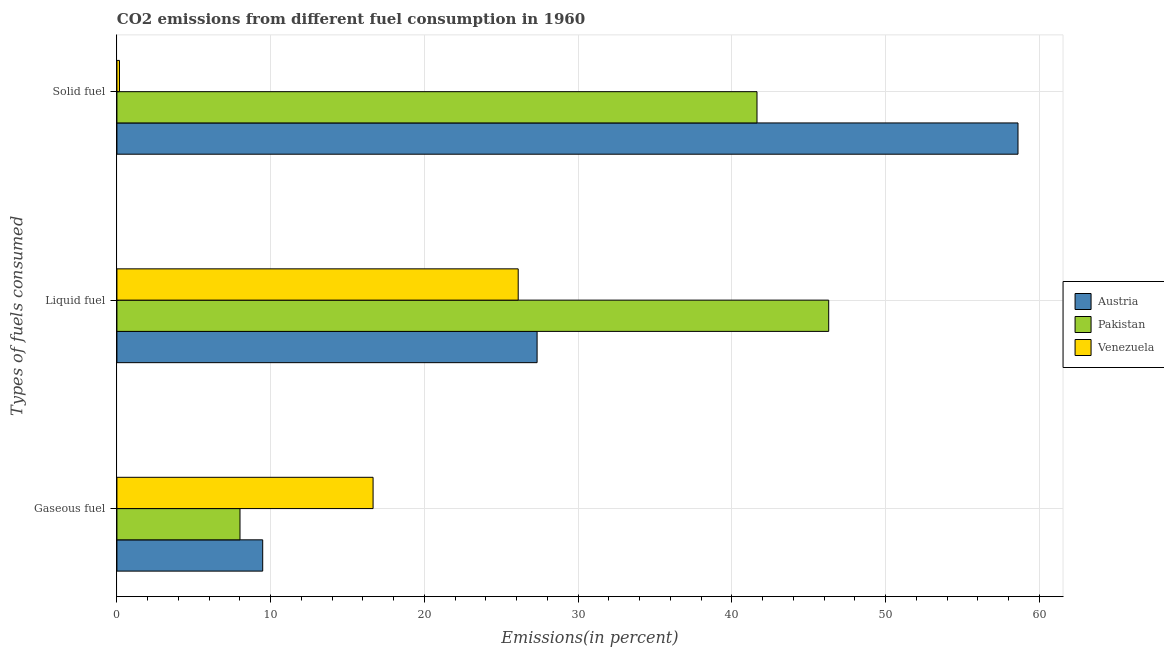How many different coloured bars are there?
Your response must be concise. 3. How many groups of bars are there?
Ensure brevity in your answer.  3. Are the number of bars on each tick of the Y-axis equal?
Your response must be concise. Yes. How many bars are there on the 2nd tick from the bottom?
Keep it short and to the point. 3. What is the label of the 1st group of bars from the top?
Ensure brevity in your answer.  Solid fuel. What is the percentage of gaseous fuel emission in Venezuela?
Offer a very short reply. 16.66. Across all countries, what is the maximum percentage of gaseous fuel emission?
Offer a very short reply. 16.66. Across all countries, what is the minimum percentage of liquid fuel emission?
Your answer should be compact. 26.1. In which country was the percentage of liquid fuel emission maximum?
Provide a succinct answer. Pakistan. In which country was the percentage of liquid fuel emission minimum?
Offer a terse response. Venezuela. What is the total percentage of solid fuel emission in the graph?
Ensure brevity in your answer.  100.41. What is the difference between the percentage of gaseous fuel emission in Austria and that in Venezuela?
Your answer should be compact. -7.18. What is the difference between the percentage of liquid fuel emission in Austria and the percentage of gaseous fuel emission in Pakistan?
Make the answer very short. 19.32. What is the average percentage of gaseous fuel emission per country?
Ensure brevity in your answer.  11.38. What is the difference between the percentage of liquid fuel emission and percentage of gaseous fuel emission in Austria?
Your answer should be very brief. 17.85. In how many countries, is the percentage of gaseous fuel emission greater than 2 %?
Your response must be concise. 3. What is the ratio of the percentage of liquid fuel emission in Pakistan to that in Austria?
Your answer should be very brief. 1.69. What is the difference between the highest and the second highest percentage of gaseous fuel emission?
Provide a succinct answer. 7.18. What is the difference between the highest and the lowest percentage of gaseous fuel emission?
Give a very brief answer. 8.66. What does the 3rd bar from the top in Liquid fuel represents?
Offer a very short reply. Austria. What does the 3rd bar from the bottom in Liquid fuel represents?
Provide a succinct answer. Venezuela. How many bars are there?
Your answer should be compact. 9. What is the difference between two consecutive major ticks on the X-axis?
Your response must be concise. 10. Are the values on the major ticks of X-axis written in scientific E-notation?
Keep it short and to the point. No. How many legend labels are there?
Offer a terse response. 3. How are the legend labels stacked?
Your answer should be very brief. Vertical. What is the title of the graph?
Your answer should be very brief. CO2 emissions from different fuel consumption in 1960. Does "French Polynesia" appear as one of the legend labels in the graph?
Your answer should be compact. No. What is the label or title of the X-axis?
Your response must be concise. Emissions(in percent). What is the label or title of the Y-axis?
Your answer should be compact. Types of fuels consumed. What is the Emissions(in percent) of Austria in Gaseous fuel?
Give a very brief answer. 9.48. What is the Emissions(in percent) of Pakistan in Gaseous fuel?
Your answer should be compact. 8.01. What is the Emissions(in percent) of Venezuela in Gaseous fuel?
Offer a terse response. 16.66. What is the Emissions(in percent) in Austria in Liquid fuel?
Your answer should be compact. 27.33. What is the Emissions(in percent) of Pakistan in Liquid fuel?
Ensure brevity in your answer.  46.3. What is the Emissions(in percent) of Venezuela in Liquid fuel?
Ensure brevity in your answer.  26.1. What is the Emissions(in percent) in Austria in Solid fuel?
Offer a terse response. 58.61. What is the Emissions(in percent) of Pakistan in Solid fuel?
Your answer should be compact. 41.63. What is the Emissions(in percent) in Venezuela in Solid fuel?
Offer a very short reply. 0.17. Across all Types of fuels consumed, what is the maximum Emissions(in percent) of Austria?
Offer a terse response. 58.61. Across all Types of fuels consumed, what is the maximum Emissions(in percent) in Pakistan?
Provide a succinct answer. 46.3. Across all Types of fuels consumed, what is the maximum Emissions(in percent) of Venezuela?
Provide a short and direct response. 26.1. Across all Types of fuels consumed, what is the minimum Emissions(in percent) of Austria?
Ensure brevity in your answer.  9.48. Across all Types of fuels consumed, what is the minimum Emissions(in percent) of Pakistan?
Offer a very short reply. 8.01. Across all Types of fuels consumed, what is the minimum Emissions(in percent) of Venezuela?
Your response must be concise. 0.17. What is the total Emissions(in percent) of Austria in the graph?
Ensure brevity in your answer.  95.42. What is the total Emissions(in percent) of Pakistan in the graph?
Give a very brief answer. 95.93. What is the total Emissions(in percent) of Venezuela in the graph?
Offer a terse response. 42.93. What is the difference between the Emissions(in percent) in Austria in Gaseous fuel and that in Liquid fuel?
Ensure brevity in your answer.  -17.85. What is the difference between the Emissions(in percent) of Pakistan in Gaseous fuel and that in Liquid fuel?
Provide a succinct answer. -38.29. What is the difference between the Emissions(in percent) in Venezuela in Gaseous fuel and that in Liquid fuel?
Keep it short and to the point. -9.44. What is the difference between the Emissions(in percent) in Austria in Gaseous fuel and that in Solid fuel?
Give a very brief answer. -49.13. What is the difference between the Emissions(in percent) of Pakistan in Gaseous fuel and that in Solid fuel?
Offer a very short reply. -33.63. What is the difference between the Emissions(in percent) of Venezuela in Gaseous fuel and that in Solid fuel?
Your response must be concise. 16.49. What is the difference between the Emissions(in percent) in Austria in Liquid fuel and that in Solid fuel?
Provide a short and direct response. -31.28. What is the difference between the Emissions(in percent) of Pakistan in Liquid fuel and that in Solid fuel?
Your answer should be very brief. 4.66. What is the difference between the Emissions(in percent) in Venezuela in Liquid fuel and that in Solid fuel?
Ensure brevity in your answer.  25.93. What is the difference between the Emissions(in percent) of Austria in Gaseous fuel and the Emissions(in percent) of Pakistan in Liquid fuel?
Your answer should be very brief. -36.81. What is the difference between the Emissions(in percent) of Austria in Gaseous fuel and the Emissions(in percent) of Venezuela in Liquid fuel?
Your response must be concise. -16.62. What is the difference between the Emissions(in percent) in Pakistan in Gaseous fuel and the Emissions(in percent) in Venezuela in Liquid fuel?
Provide a succinct answer. -18.1. What is the difference between the Emissions(in percent) in Austria in Gaseous fuel and the Emissions(in percent) in Pakistan in Solid fuel?
Offer a terse response. -32.15. What is the difference between the Emissions(in percent) in Austria in Gaseous fuel and the Emissions(in percent) in Venezuela in Solid fuel?
Make the answer very short. 9.32. What is the difference between the Emissions(in percent) of Pakistan in Gaseous fuel and the Emissions(in percent) of Venezuela in Solid fuel?
Your response must be concise. 7.84. What is the difference between the Emissions(in percent) of Austria in Liquid fuel and the Emissions(in percent) of Pakistan in Solid fuel?
Give a very brief answer. -14.3. What is the difference between the Emissions(in percent) of Austria in Liquid fuel and the Emissions(in percent) of Venezuela in Solid fuel?
Offer a very short reply. 27.16. What is the difference between the Emissions(in percent) of Pakistan in Liquid fuel and the Emissions(in percent) of Venezuela in Solid fuel?
Provide a succinct answer. 46.13. What is the average Emissions(in percent) of Austria per Types of fuels consumed?
Offer a terse response. 31.81. What is the average Emissions(in percent) of Pakistan per Types of fuels consumed?
Make the answer very short. 31.98. What is the average Emissions(in percent) in Venezuela per Types of fuels consumed?
Provide a succinct answer. 14.31. What is the difference between the Emissions(in percent) of Austria and Emissions(in percent) of Pakistan in Gaseous fuel?
Provide a short and direct response. 1.48. What is the difference between the Emissions(in percent) of Austria and Emissions(in percent) of Venezuela in Gaseous fuel?
Your answer should be compact. -7.18. What is the difference between the Emissions(in percent) in Pakistan and Emissions(in percent) in Venezuela in Gaseous fuel?
Give a very brief answer. -8.66. What is the difference between the Emissions(in percent) of Austria and Emissions(in percent) of Pakistan in Liquid fuel?
Your answer should be very brief. -18.97. What is the difference between the Emissions(in percent) in Austria and Emissions(in percent) in Venezuela in Liquid fuel?
Offer a terse response. 1.23. What is the difference between the Emissions(in percent) of Pakistan and Emissions(in percent) of Venezuela in Liquid fuel?
Your response must be concise. 20.2. What is the difference between the Emissions(in percent) in Austria and Emissions(in percent) in Pakistan in Solid fuel?
Provide a succinct answer. 16.98. What is the difference between the Emissions(in percent) in Austria and Emissions(in percent) in Venezuela in Solid fuel?
Offer a terse response. 58.44. What is the difference between the Emissions(in percent) in Pakistan and Emissions(in percent) in Venezuela in Solid fuel?
Your response must be concise. 41.47. What is the ratio of the Emissions(in percent) in Austria in Gaseous fuel to that in Liquid fuel?
Offer a terse response. 0.35. What is the ratio of the Emissions(in percent) in Pakistan in Gaseous fuel to that in Liquid fuel?
Provide a succinct answer. 0.17. What is the ratio of the Emissions(in percent) in Venezuela in Gaseous fuel to that in Liquid fuel?
Provide a succinct answer. 0.64. What is the ratio of the Emissions(in percent) of Austria in Gaseous fuel to that in Solid fuel?
Make the answer very short. 0.16. What is the ratio of the Emissions(in percent) of Pakistan in Gaseous fuel to that in Solid fuel?
Provide a short and direct response. 0.19. What is the ratio of the Emissions(in percent) of Venezuela in Gaseous fuel to that in Solid fuel?
Your answer should be compact. 99.73. What is the ratio of the Emissions(in percent) of Austria in Liquid fuel to that in Solid fuel?
Offer a very short reply. 0.47. What is the ratio of the Emissions(in percent) in Pakistan in Liquid fuel to that in Solid fuel?
Give a very brief answer. 1.11. What is the ratio of the Emissions(in percent) in Venezuela in Liquid fuel to that in Solid fuel?
Offer a terse response. 156.23. What is the difference between the highest and the second highest Emissions(in percent) in Austria?
Offer a very short reply. 31.28. What is the difference between the highest and the second highest Emissions(in percent) in Pakistan?
Offer a very short reply. 4.66. What is the difference between the highest and the second highest Emissions(in percent) of Venezuela?
Make the answer very short. 9.44. What is the difference between the highest and the lowest Emissions(in percent) of Austria?
Give a very brief answer. 49.13. What is the difference between the highest and the lowest Emissions(in percent) in Pakistan?
Your answer should be compact. 38.29. What is the difference between the highest and the lowest Emissions(in percent) in Venezuela?
Your answer should be compact. 25.93. 